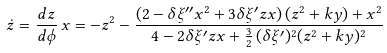Convert formula to latex. <formula><loc_0><loc_0><loc_500><loc_500>\dot { z } = \frac { d z } { d \phi } \, x = - z ^ { 2 } - \frac { ( 2 - \delta \xi ^ { \prime \prime } x ^ { 2 } + 3 \delta \xi ^ { \prime } z x ) \, ( z ^ { 2 } + k y ) + x ^ { 2 } } { 4 - 2 \delta \xi ^ { \prime } z x + \frac { 3 } { 2 } \, ( \delta \xi ^ { \prime } ) ^ { 2 } ( z ^ { 2 } + k y ) ^ { 2 } }</formula> 